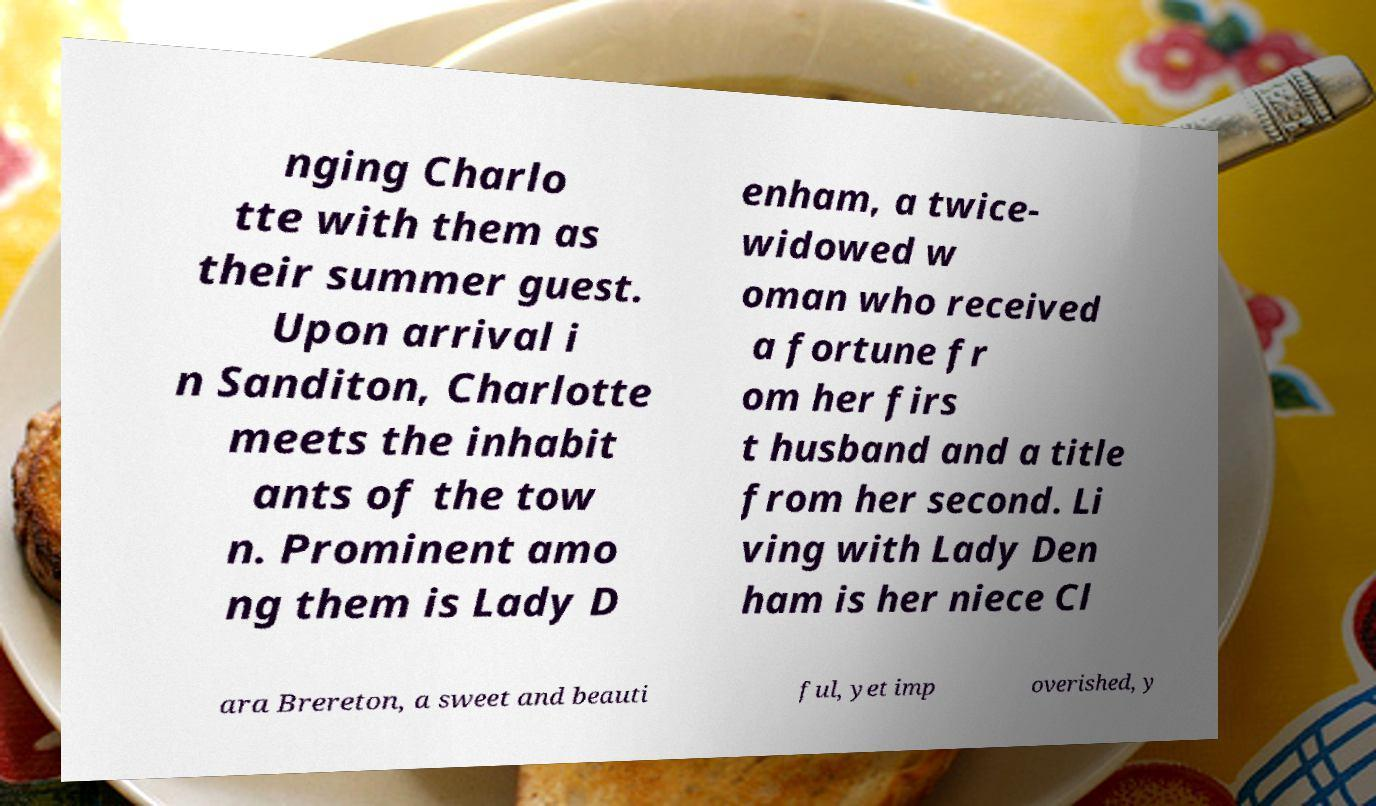Could you assist in decoding the text presented in this image and type it out clearly? nging Charlo tte with them as their summer guest. Upon arrival i n Sanditon, Charlotte meets the inhabit ants of the tow n. Prominent amo ng them is Lady D enham, a twice- widowed w oman who received a fortune fr om her firs t husband and a title from her second. Li ving with Lady Den ham is her niece Cl ara Brereton, a sweet and beauti ful, yet imp overished, y 